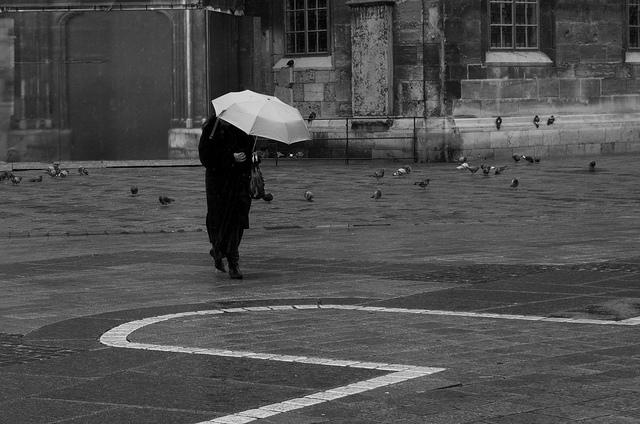What is the person hiding behind? umbrella 